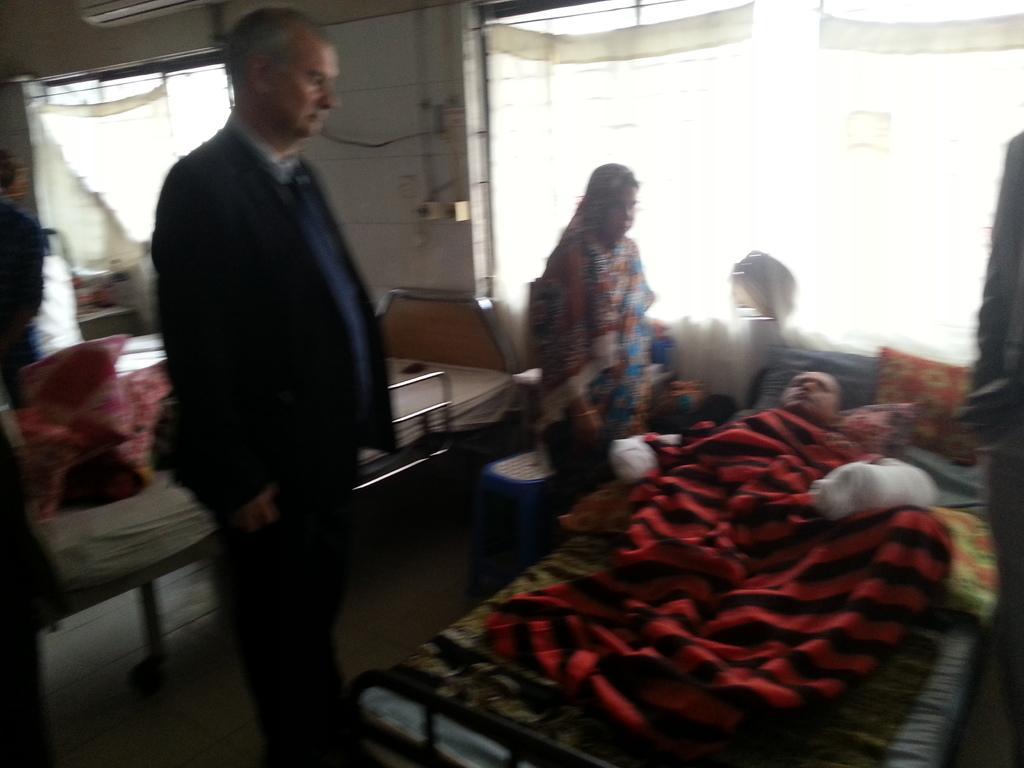Could you give a brief overview of what you see in this image? In this image I can see few beds and few people. On the right side of this image I can see a person on one bed. I can also see this image is little bit blurry. 